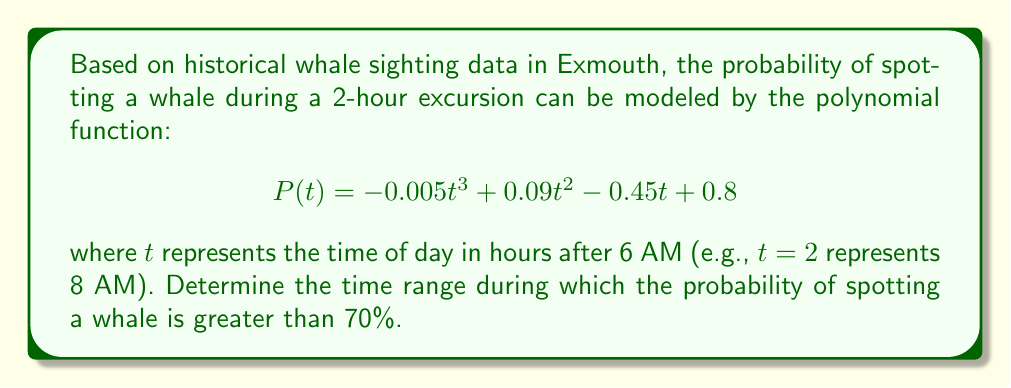Can you answer this question? To solve this problem, we need to follow these steps:

1) Set up the inequality:
   $$P(t) > 0.7$$
   $$-0.005t^3 + 0.09t^2 - 0.45t + 0.8 > 0.7$$

2) Rearrange the inequality:
   $$-0.005t^3 + 0.09t^2 - 0.45t + 0.1 > 0$$

3) Let's call the left side of the inequality $f(t)$:
   $$f(t) = -0.005t^3 + 0.09t^2 - 0.45t + 0.1$$

4) To solve this inequality, we need to find the roots of $f(t) = 0$. This can be done using a graphing calculator or computer software. The roots are approximately:
   $$t_1 \approx 1.04, t_2 \approx 5.64, t_3 \approx 11.32$$

5) Sketch the graph of $f(t)$ to determine where it's positive:
   [asy]
   import graph;
   size(200,150);
   real f(real x) {return -0.005x^3 + 0.09x^2 - 0.45x + 0.1;}
   draw(graph(f,0,12));
   draw((0,0)--(12,0),arrow=Arrow(TeXHead));
   draw((0,-0.5)--(0,0.5),arrow=Arrow(TeXHead));
   label("$t$",(12,0),E);
   label("$f(t)$",(0,0.5),N);
   dot((1.04,0));
   dot((5.64,0));
   dot((11.32,0));
   label("$1.04$",(1.04,0),S);
   label("$5.64$",(5.64,0),S);
   label("$11.32$",(11.32,0),S);
   [/asy]

6) From the graph, we can see that $f(t) > 0$ when $1.04 < t < 5.64$.

7) Convert these $t$ values back to actual times:
   $t = 1.04$ corresponds to 7:02 AM (6:00 AM + 1.04 hours)
   $t = 5.64$ corresponds to 11:38 AM (6:00 AM + 5.64 hours)

Therefore, the probability of spotting a whale is greater than 70% between 7:02 AM and 11:38 AM.
Answer: 7:02 AM to 11:38 AM 